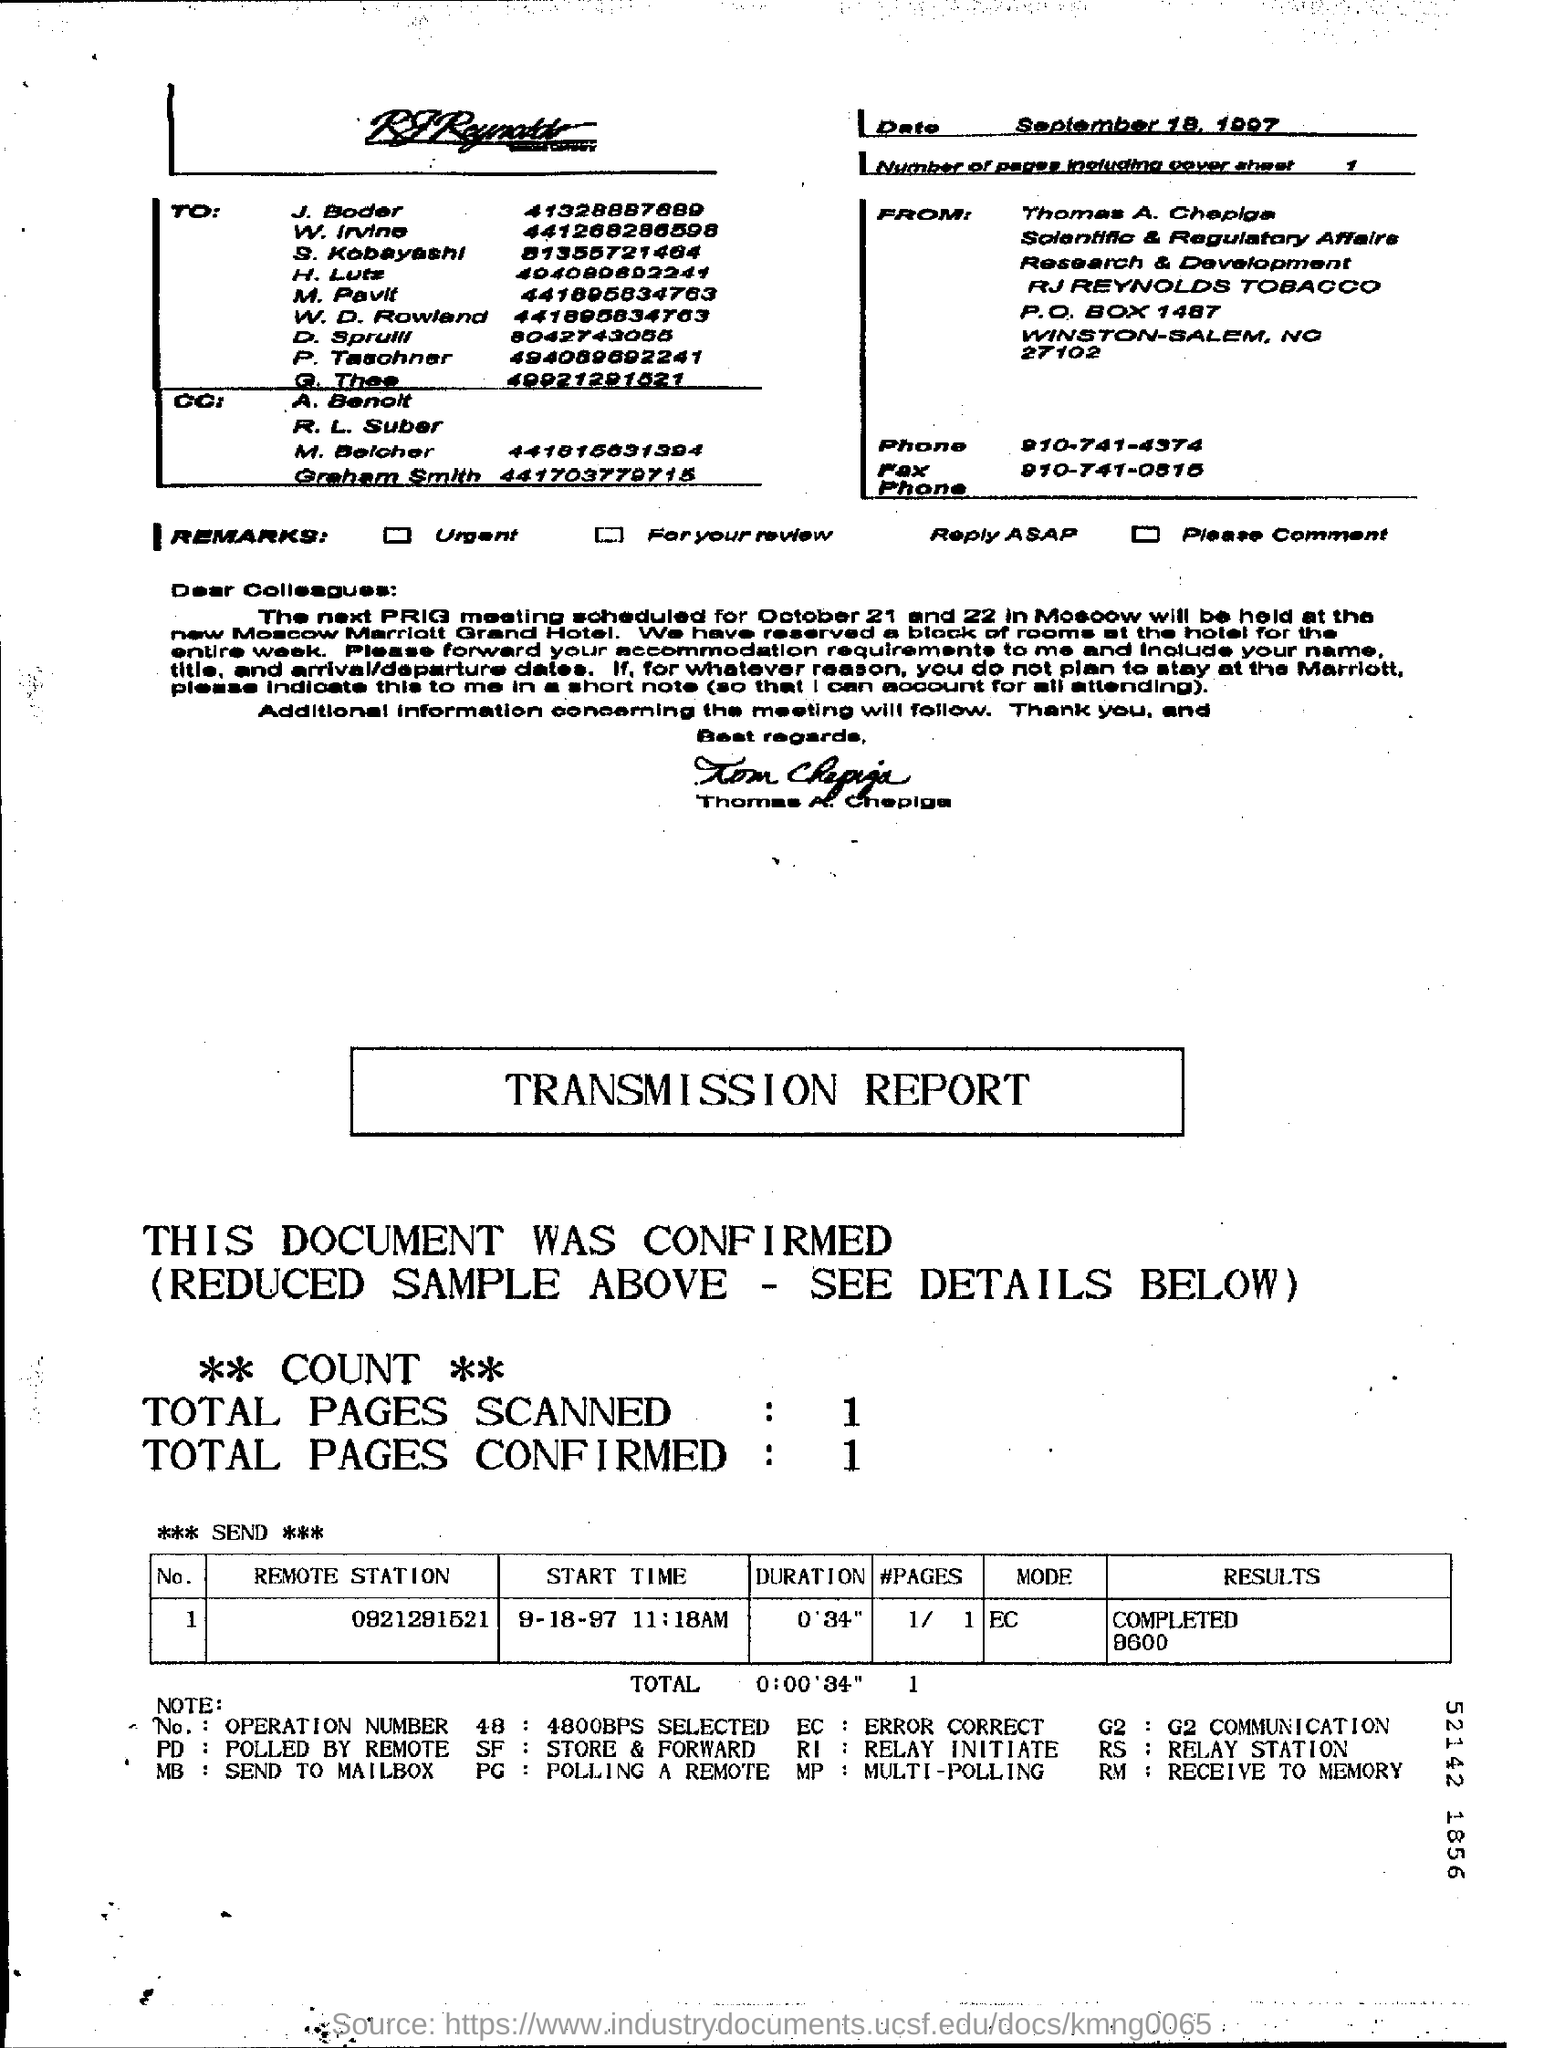How many total pages are scanned ?
Ensure brevity in your answer.  1. How many total pages are confirmed ?
Ensure brevity in your answer.  1. What is the p.o box number of rj reynolds tobacco ?
Your answer should be very brief. 1487. 